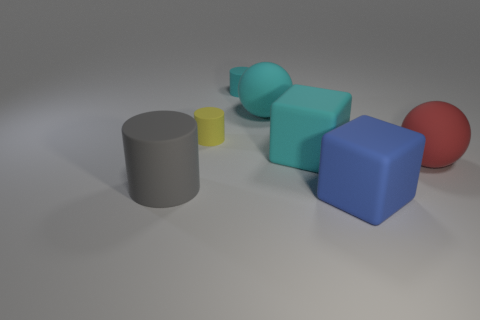Are there an equal number of big blue rubber cubes that are behind the yellow matte thing and gray things that are in front of the large cyan matte cube?
Give a very brief answer. No. There is a large rubber thing that is in front of the gray rubber cylinder; how many cyan rubber balls are on the right side of it?
Keep it short and to the point. 0. There is a big thing behind the small yellow rubber thing; is it the same color as the rubber cylinder left of the small yellow rubber thing?
Offer a terse response. No. There is another ball that is the same size as the red sphere; what is it made of?
Provide a short and direct response. Rubber. What shape is the large cyan object in front of the large sphere that is to the left of the rubber sphere in front of the large cyan cube?
Make the answer very short. Cube. What shape is the blue matte object that is the same size as the cyan matte block?
Keep it short and to the point. Cube. There is a matte ball that is in front of the tiny cylinder in front of the small cyan rubber cylinder; how many blue rubber things are right of it?
Provide a short and direct response. 0. Is the number of big cyan things on the left side of the tiny yellow rubber cylinder greater than the number of tiny rubber things in front of the large blue block?
Your response must be concise. No. What number of other rubber objects have the same shape as the yellow thing?
Provide a succinct answer. 2. How many things are tiny yellow cylinders to the left of the large cyan cube or matte things behind the blue cube?
Offer a terse response. 6. 